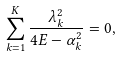<formula> <loc_0><loc_0><loc_500><loc_500>\sum _ { k = 1 } ^ { K } \frac { \lambda _ { k } ^ { 2 } } { 4 E - \alpha _ { k } ^ { 2 } } = 0 ,</formula> 